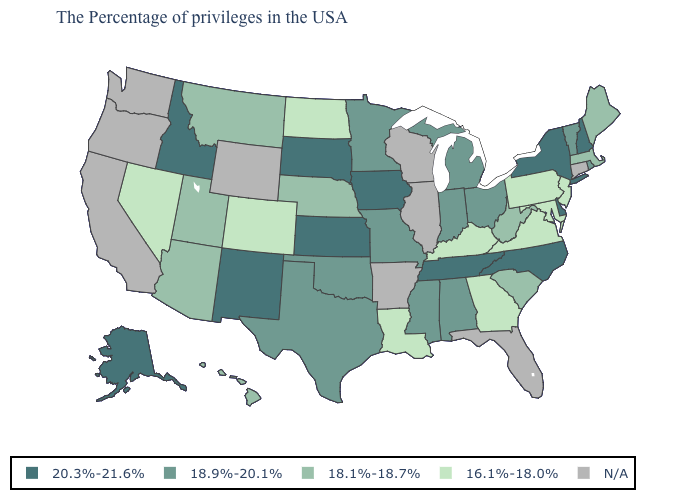Which states have the lowest value in the West?
Write a very short answer. Colorado, Nevada. What is the highest value in the USA?
Keep it brief. 20.3%-21.6%. What is the value of Nebraska?
Keep it brief. 18.1%-18.7%. What is the value of Wisconsin?
Give a very brief answer. N/A. What is the highest value in states that border Nebraska?
Concise answer only. 20.3%-21.6%. Which states hav the highest value in the West?
Write a very short answer. New Mexico, Idaho, Alaska. Which states have the lowest value in the USA?
Give a very brief answer. New Jersey, Maryland, Pennsylvania, Virginia, Georgia, Kentucky, Louisiana, North Dakota, Colorado, Nevada. What is the value of Illinois?
Write a very short answer. N/A. Name the states that have a value in the range 16.1%-18.0%?
Quick response, please. New Jersey, Maryland, Pennsylvania, Virginia, Georgia, Kentucky, Louisiana, North Dakota, Colorado, Nevada. What is the value of Alaska?
Keep it brief. 20.3%-21.6%. Name the states that have a value in the range N/A?
Answer briefly. Connecticut, Florida, Wisconsin, Illinois, Arkansas, Wyoming, California, Washington, Oregon. What is the value of North Carolina?
Answer briefly. 20.3%-21.6%. Name the states that have a value in the range 18.9%-20.1%?
Short answer required. Rhode Island, Vermont, Ohio, Michigan, Indiana, Alabama, Mississippi, Missouri, Minnesota, Oklahoma, Texas. Name the states that have a value in the range 20.3%-21.6%?
Answer briefly. New Hampshire, New York, Delaware, North Carolina, Tennessee, Iowa, Kansas, South Dakota, New Mexico, Idaho, Alaska. 